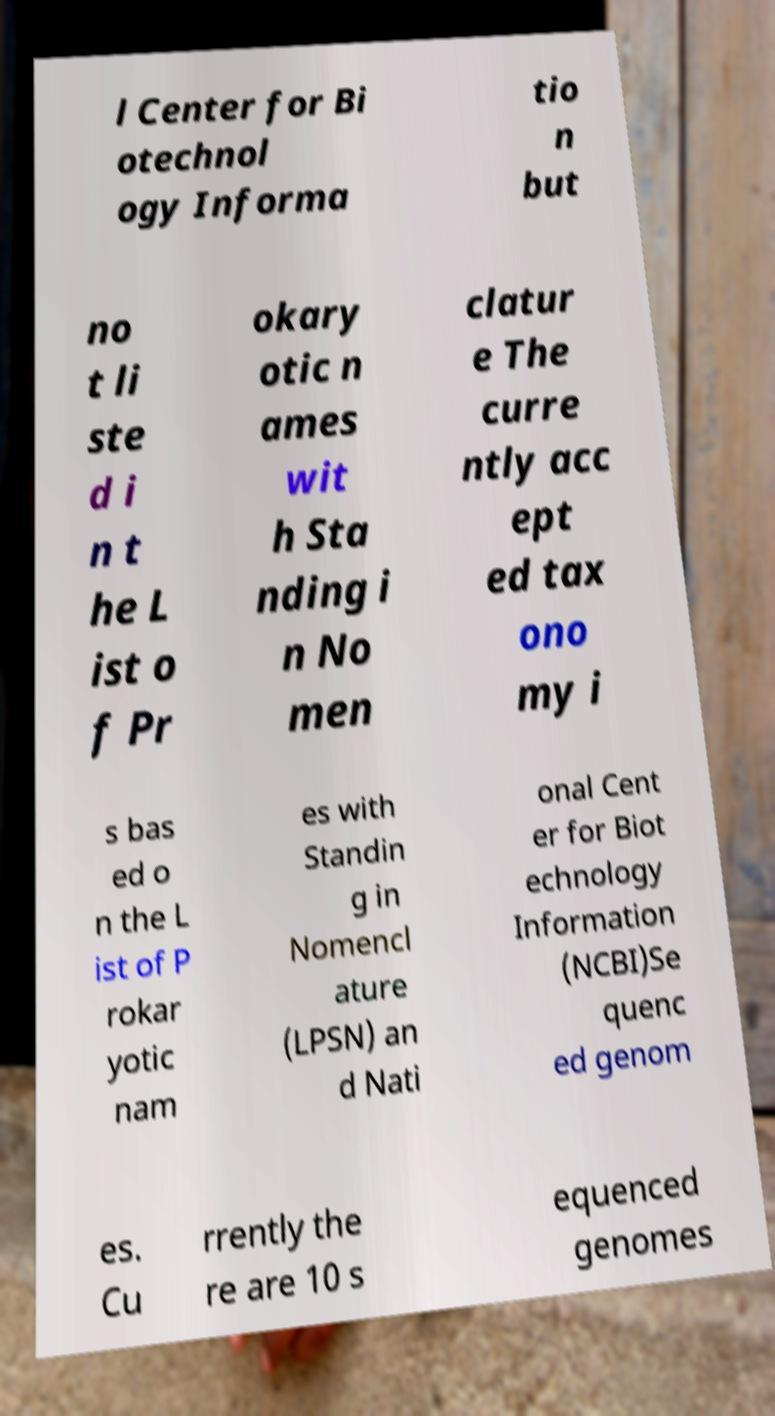What messages or text are displayed in this image? I need them in a readable, typed format. l Center for Bi otechnol ogy Informa tio n but no t li ste d i n t he L ist o f Pr okary otic n ames wit h Sta nding i n No men clatur e The curre ntly acc ept ed tax ono my i s bas ed o n the L ist of P rokar yotic nam es with Standin g in Nomencl ature (LPSN) an d Nati onal Cent er for Biot echnology Information (NCBI)Se quenc ed genom es. Cu rrently the re are 10 s equenced genomes 